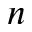Convert formula to latex. <formula><loc_0><loc_0><loc_500><loc_500>n</formula> 